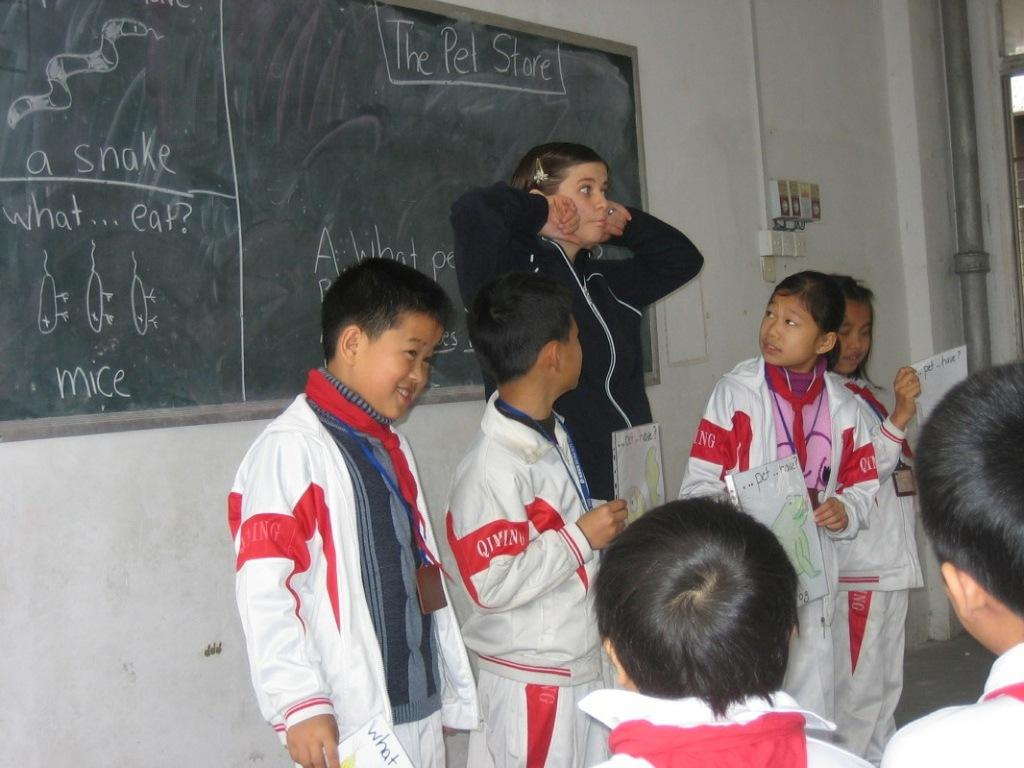Provide a one-sentence caption for the provided image. Students wearing white jackets that say QIMING on them. 